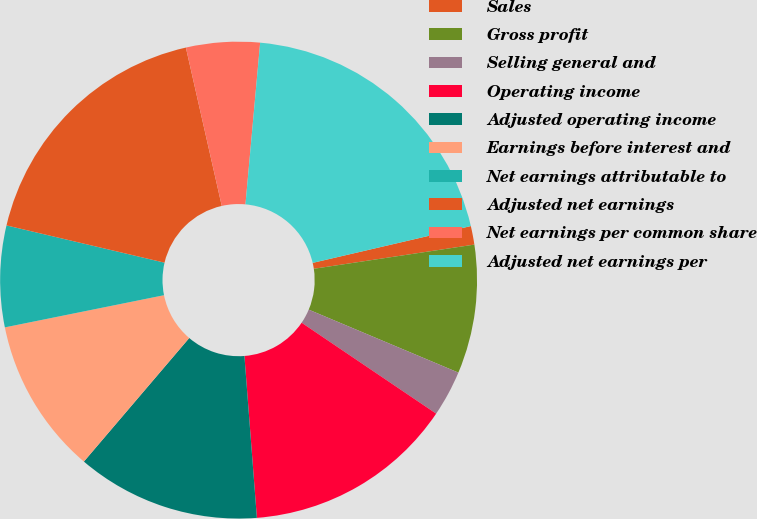Convert chart. <chart><loc_0><loc_0><loc_500><loc_500><pie_chart><fcel>Sales<fcel>Gross profit<fcel>Selling general and<fcel>Operating income<fcel>Adjusted operating income<fcel>Earnings before interest and<fcel>Net earnings attributable to<fcel>Adjusted net earnings<fcel>Net earnings per common share<fcel>Adjusted net earnings per<nl><fcel>1.26%<fcel>8.72%<fcel>3.12%<fcel>14.32%<fcel>12.46%<fcel>10.59%<fcel>6.86%<fcel>17.77%<fcel>4.99%<fcel>19.92%<nl></chart> 